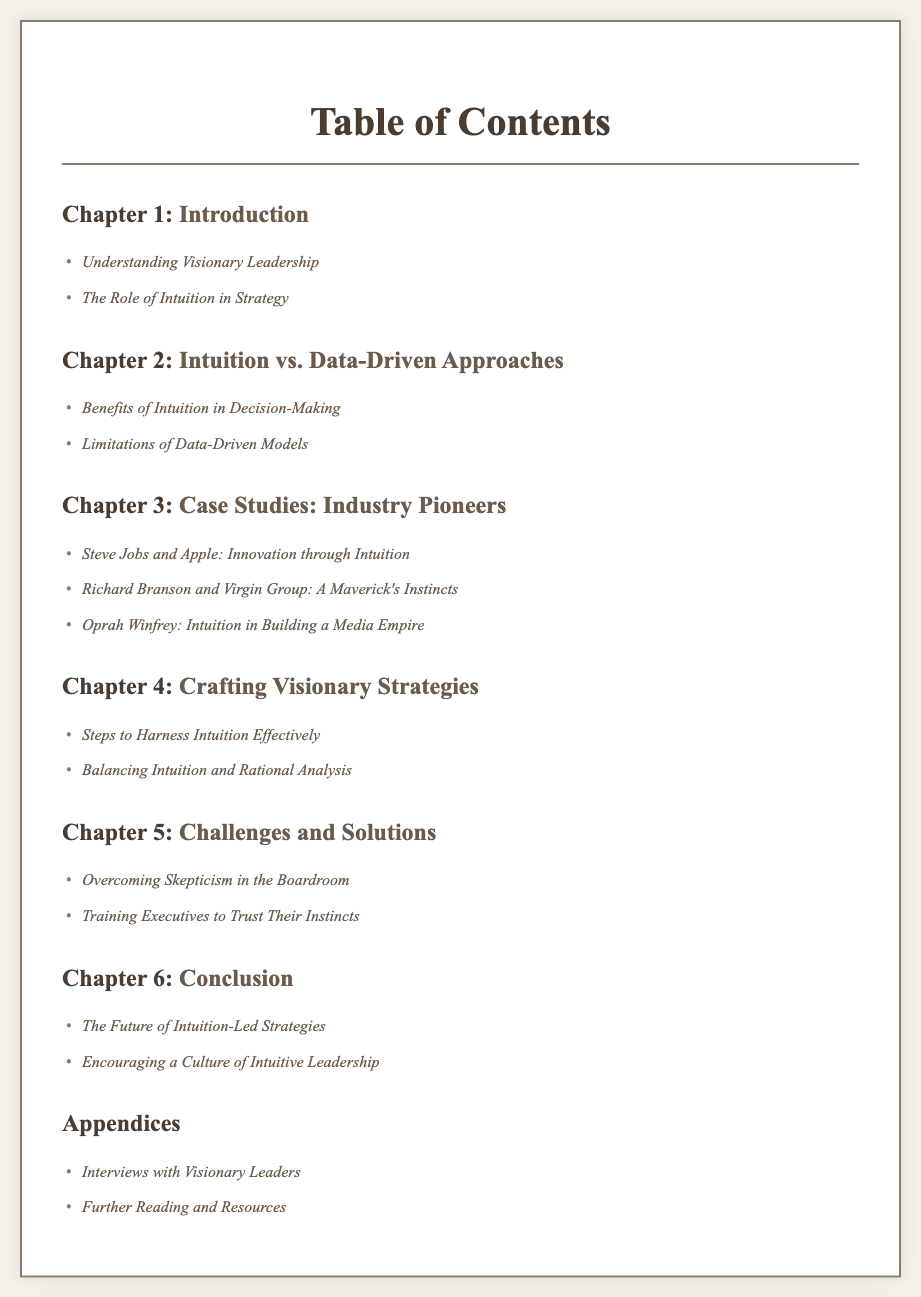What is the title of the document? The title is presented at the top of the rendered document.
Answer: Crafting Visionary Strategies: Intuition-Led Success Stories from Industry Pioneers How many chapters are there in total? The total number of chapters is visible in the Table of Contents, counting all the chapters listed.
Answer: 6 What is the first section in Chapter 1? The first section of Chapter 1 is clearly listed in the Table of Contents.
Answer: Understanding Visionary Leadership Which industry pioneer is associated with Apple? The document names a specific individual connected with Apple in the case studies.
Answer: Steve Jobs What chapter discusses the challenges and solutions? The chapter addressing challenges and solutions can be identified by its title listed in the Table of Contents.
Answer: Chapter 5 How many case studies are presented in Chapter 3? The number of case studies can be inferred by counting the sections in Chapter 3.
Answer: 3 What is the last section of the document? The last section is found at the end of the Table of Contents and indicates its placement.
Answer: Further Reading and Resources What is the focus of Chapter 4? The focus of Chapter 4 can be determined based on the title and sections related to it.
Answer: Crafting Visionary Strategies What does the document suggest for overcoming skepticism? The solution for overcoming skepticism is detailed in Chapter 5's sections.
Answer: Overcoming Skepticism in the Boardroom 